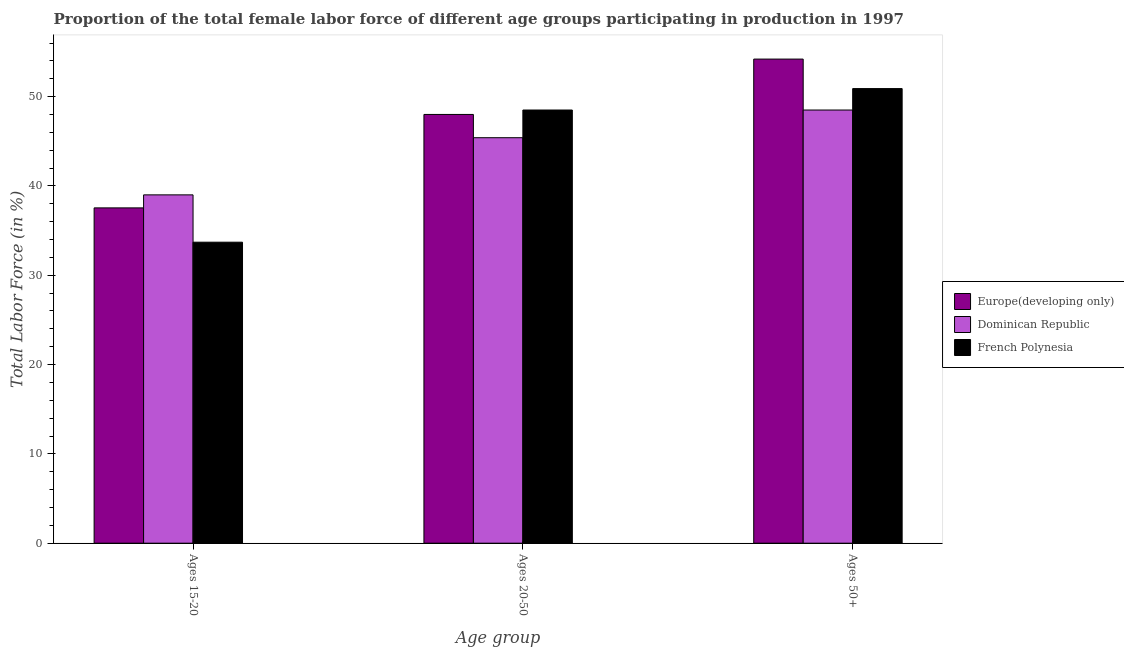How many groups of bars are there?
Your answer should be very brief. 3. Are the number of bars on each tick of the X-axis equal?
Give a very brief answer. Yes. What is the label of the 3rd group of bars from the left?
Make the answer very short. Ages 50+. What is the percentage of female labor force within the age group 20-50 in Europe(developing only)?
Offer a very short reply. 48. Across all countries, what is the maximum percentage of female labor force within the age group 20-50?
Keep it short and to the point. 48.5. Across all countries, what is the minimum percentage of female labor force within the age group 15-20?
Provide a short and direct response. 33.7. In which country was the percentage of female labor force above age 50 maximum?
Ensure brevity in your answer.  Europe(developing only). In which country was the percentage of female labor force above age 50 minimum?
Offer a terse response. Dominican Republic. What is the total percentage of female labor force within the age group 15-20 in the graph?
Ensure brevity in your answer.  110.24. What is the difference between the percentage of female labor force within the age group 20-50 in French Polynesia and that in Europe(developing only)?
Your answer should be very brief. 0.5. What is the difference between the percentage of female labor force within the age group 20-50 in Dominican Republic and the percentage of female labor force above age 50 in French Polynesia?
Provide a short and direct response. -5.5. What is the average percentage of female labor force above age 50 per country?
Give a very brief answer. 51.2. What is the difference between the percentage of female labor force within the age group 20-50 and percentage of female labor force within the age group 15-20 in Dominican Republic?
Provide a short and direct response. 6.4. In how many countries, is the percentage of female labor force within the age group 20-50 greater than 12 %?
Make the answer very short. 3. What is the ratio of the percentage of female labor force above age 50 in French Polynesia to that in Dominican Republic?
Provide a succinct answer. 1.05. Is the difference between the percentage of female labor force within the age group 20-50 in Europe(developing only) and French Polynesia greater than the difference between the percentage of female labor force above age 50 in Europe(developing only) and French Polynesia?
Offer a terse response. No. What is the difference between the highest and the second highest percentage of female labor force within the age group 20-50?
Offer a terse response. 0.5. What is the difference between the highest and the lowest percentage of female labor force within the age group 20-50?
Offer a very short reply. 3.1. Is the sum of the percentage of female labor force above age 50 in Dominican Republic and Europe(developing only) greater than the maximum percentage of female labor force within the age group 15-20 across all countries?
Ensure brevity in your answer.  Yes. What does the 3rd bar from the left in Ages 20-50 represents?
Offer a very short reply. French Polynesia. What does the 3rd bar from the right in Ages 20-50 represents?
Provide a short and direct response. Europe(developing only). Is it the case that in every country, the sum of the percentage of female labor force within the age group 15-20 and percentage of female labor force within the age group 20-50 is greater than the percentage of female labor force above age 50?
Give a very brief answer. Yes. How many bars are there?
Keep it short and to the point. 9. Are all the bars in the graph horizontal?
Offer a very short reply. No. What is the difference between two consecutive major ticks on the Y-axis?
Keep it short and to the point. 10. Are the values on the major ticks of Y-axis written in scientific E-notation?
Make the answer very short. No. How many legend labels are there?
Give a very brief answer. 3. How are the legend labels stacked?
Give a very brief answer. Vertical. What is the title of the graph?
Provide a succinct answer. Proportion of the total female labor force of different age groups participating in production in 1997. What is the label or title of the X-axis?
Ensure brevity in your answer.  Age group. What is the Total Labor Force (in %) in Europe(developing only) in Ages 15-20?
Keep it short and to the point. 37.54. What is the Total Labor Force (in %) of Dominican Republic in Ages 15-20?
Your answer should be very brief. 39. What is the Total Labor Force (in %) in French Polynesia in Ages 15-20?
Offer a very short reply. 33.7. What is the Total Labor Force (in %) in Europe(developing only) in Ages 20-50?
Ensure brevity in your answer.  48. What is the Total Labor Force (in %) in Dominican Republic in Ages 20-50?
Offer a very short reply. 45.4. What is the Total Labor Force (in %) in French Polynesia in Ages 20-50?
Your answer should be compact. 48.5. What is the Total Labor Force (in %) in Europe(developing only) in Ages 50+?
Your answer should be compact. 54.2. What is the Total Labor Force (in %) of Dominican Republic in Ages 50+?
Give a very brief answer. 48.5. What is the Total Labor Force (in %) in French Polynesia in Ages 50+?
Offer a very short reply. 50.9. Across all Age group, what is the maximum Total Labor Force (in %) of Europe(developing only)?
Your answer should be very brief. 54.2. Across all Age group, what is the maximum Total Labor Force (in %) in Dominican Republic?
Make the answer very short. 48.5. Across all Age group, what is the maximum Total Labor Force (in %) in French Polynesia?
Your answer should be very brief. 50.9. Across all Age group, what is the minimum Total Labor Force (in %) of Europe(developing only)?
Make the answer very short. 37.54. Across all Age group, what is the minimum Total Labor Force (in %) in Dominican Republic?
Provide a short and direct response. 39. Across all Age group, what is the minimum Total Labor Force (in %) in French Polynesia?
Make the answer very short. 33.7. What is the total Total Labor Force (in %) of Europe(developing only) in the graph?
Keep it short and to the point. 139.75. What is the total Total Labor Force (in %) of Dominican Republic in the graph?
Make the answer very short. 132.9. What is the total Total Labor Force (in %) in French Polynesia in the graph?
Provide a succinct answer. 133.1. What is the difference between the Total Labor Force (in %) in Europe(developing only) in Ages 15-20 and that in Ages 20-50?
Give a very brief answer. -10.46. What is the difference between the Total Labor Force (in %) of French Polynesia in Ages 15-20 and that in Ages 20-50?
Make the answer very short. -14.8. What is the difference between the Total Labor Force (in %) in Europe(developing only) in Ages 15-20 and that in Ages 50+?
Provide a short and direct response. -16.66. What is the difference between the Total Labor Force (in %) in Dominican Republic in Ages 15-20 and that in Ages 50+?
Ensure brevity in your answer.  -9.5. What is the difference between the Total Labor Force (in %) in French Polynesia in Ages 15-20 and that in Ages 50+?
Make the answer very short. -17.2. What is the difference between the Total Labor Force (in %) in Europe(developing only) in Ages 20-50 and that in Ages 50+?
Offer a very short reply. -6.2. What is the difference between the Total Labor Force (in %) of Dominican Republic in Ages 20-50 and that in Ages 50+?
Your answer should be compact. -3.1. What is the difference between the Total Labor Force (in %) of Europe(developing only) in Ages 15-20 and the Total Labor Force (in %) of Dominican Republic in Ages 20-50?
Your response must be concise. -7.86. What is the difference between the Total Labor Force (in %) in Europe(developing only) in Ages 15-20 and the Total Labor Force (in %) in French Polynesia in Ages 20-50?
Offer a terse response. -10.96. What is the difference between the Total Labor Force (in %) in Dominican Republic in Ages 15-20 and the Total Labor Force (in %) in French Polynesia in Ages 20-50?
Offer a very short reply. -9.5. What is the difference between the Total Labor Force (in %) in Europe(developing only) in Ages 15-20 and the Total Labor Force (in %) in Dominican Republic in Ages 50+?
Offer a very short reply. -10.96. What is the difference between the Total Labor Force (in %) of Europe(developing only) in Ages 15-20 and the Total Labor Force (in %) of French Polynesia in Ages 50+?
Provide a succinct answer. -13.36. What is the difference between the Total Labor Force (in %) of Dominican Republic in Ages 15-20 and the Total Labor Force (in %) of French Polynesia in Ages 50+?
Provide a succinct answer. -11.9. What is the difference between the Total Labor Force (in %) of Europe(developing only) in Ages 20-50 and the Total Labor Force (in %) of Dominican Republic in Ages 50+?
Offer a terse response. -0.5. What is the difference between the Total Labor Force (in %) in Europe(developing only) in Ages 20-50 and the Total Labor Force (in %) in French Polynesia in Ages 50+?
Your answer should be compact. -2.9. What is the difference between the Total Labor Force (in %) of Dominican Republic in Ages 20-50 and the Total Labor Force (in %) of French Polynesia in Ages 50+?
Make the answer very short. -5.5. What is the average Total Labor Force (in %) in Europe(developing only) per Age group?
Your answer should be very brief. 46.58. What is the average Total Labor Force (in %) of Dominican Republic per Age group?
Provide a short and direct response. 44.3. What is the average Total Labor Force (in %) in French Polynesia per Age group?
Give a very brief answer. 44.37. What is the difference between the Total Labor Force (in %) in Europe(developing only) and Total Labor Force (in %) in Dominican Republic in Ages 15-20?
Ensure brevity in your answer.  -1.46. What is the difference between the Total Labor Force (in %) of Europe(developing only) and Total Labor Force (in %) of French Polynesia in Ages 15-20?
Make the answer very short. 3.84. What is the difference between the Total Labor Force (in %) in Dominican Republic and Total Labor Force (in %) in French Polynesia in Ages 15-20?
Give a very brief answer. 5.3. What is the difference between the Total Labor Force (in %) in Europe(developing only) and Total Labor Force (in %) in Dominican Republic in Ages 20-50?
Give a very brief answer. 2.6. What is the difference between the Total Labor Force (in %) in Europe(developing only) and Total Labor Force (in %) in French Polynesia in Ages 20-50?
Offer a terse response. -0.5. What is the difference between the Total Labor Force (in %) of Europe(developing only) and Total Labor Force (in %) of Dominican Republic in Ages 50+?
Make the answer very short. 5.7. What is the difference between the Total Labor Force (in %) in Europe(developing only) and Total Labor Force (in %) in French Polynesia in Ages 50+?
Offer a terse response. 3.3. What is the difference between the Total Labor Force (in %) in Dominican Republic and Total Labor Force (in %) in French Polynesia in Ages 50+?
Your answer should be compact. -2.4. What is the ratio of the Total Labor Force (in %) in Europe(developing only) in Ages 15-20 to that in Ages 20-50?
Make the answer very short. 0.78. What is the ratio of the Total Labor Force (in %) in Dominican Republic in Ages 15-20 to that in Ages 20-50?
Provide a succinct answer. 0.86. What is the ratio of the Total Labor Force (in %) in French Polynesia in Ages 15-20 to that in Ages 20-50?
Your answer should be compact. 0.69. What is the ratio of the Total Labor Force (in %) in Europe(developing only) in Ages 15-20 to that in Ages 50+?
Provide a succinct answer. 0.69. What is the ratio of the Total Labor Force (in %) of Dominican Republic in Ages 15-20 to that in Ages 50+?
Ensure brevity in your answer.  0.8. What is the ratio of the Total Labor Force (in %) in French Polynesia in Ages 15-20 to that in Ages 50+?
Your response must be concise. 0.66. What is the ratio of the Total Labor Force (in %) in Europe(developing only) in Ages 20-50 to that in Ages 50+?
Make the answer very short. 0.89. What is the ratio of the Total Labor Force (in %) of Dominican Republic in Ages 20-50 to that in Ages 50+?
Keep it short and to the point. 0.94. What is the ratio of the Total Labor Force (in %) in French Polynesia in Ages 20-50 to that in Ages 50+?
Ensure brevity in your answer.  0.95. What is the difference between the highest and the second highest Total Labor Force (in %) of Europe(developing only)?
Keep it short and to the point. 6.2. What is the difference between the highest and the second highest Total Labor Force (in %) of French Polynesia?
Offer a terse response. 2.4. What is the difference between the highest and the lowest Total Labor Force (in %) in Europe(developing only)?
Ensure brevity in your answer.  16.66. 